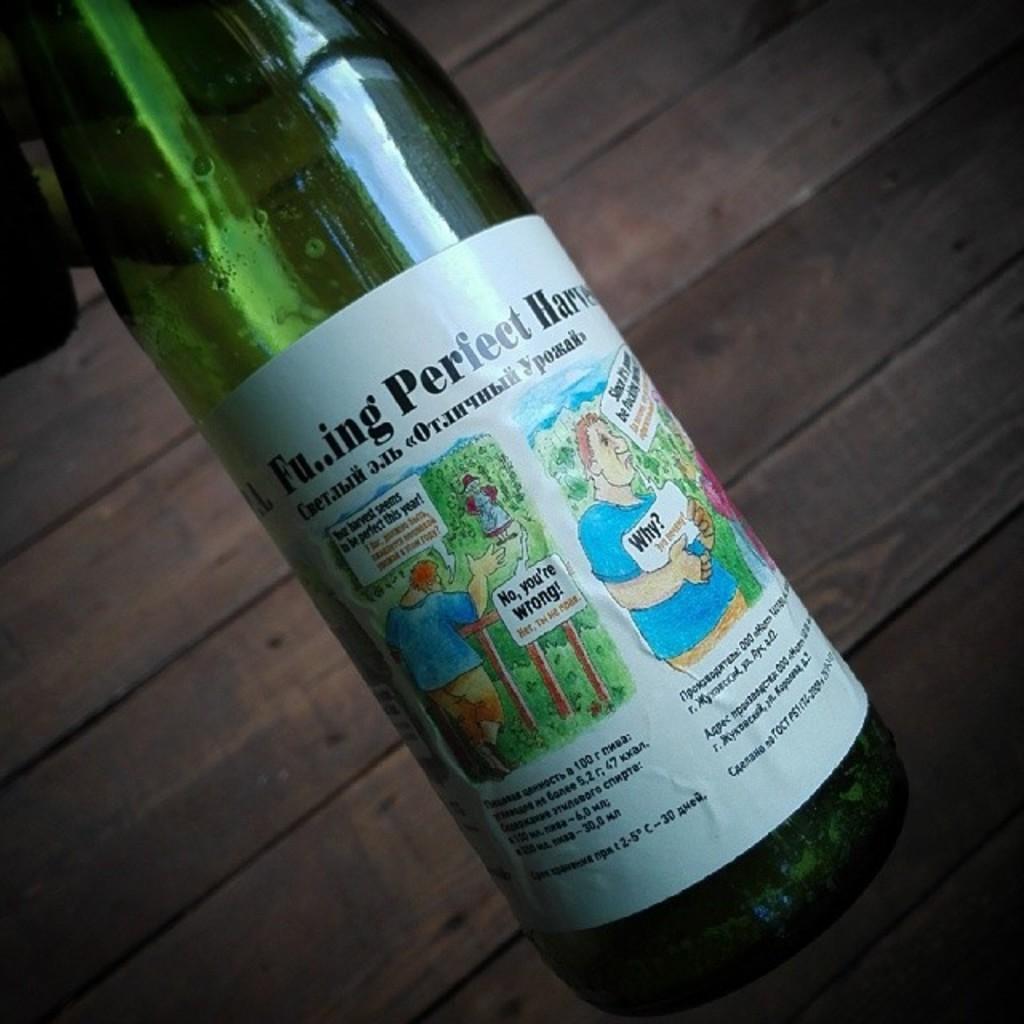What quality is the harvest from this bottle?
Ensure brevity in your answer.  Perfect. 